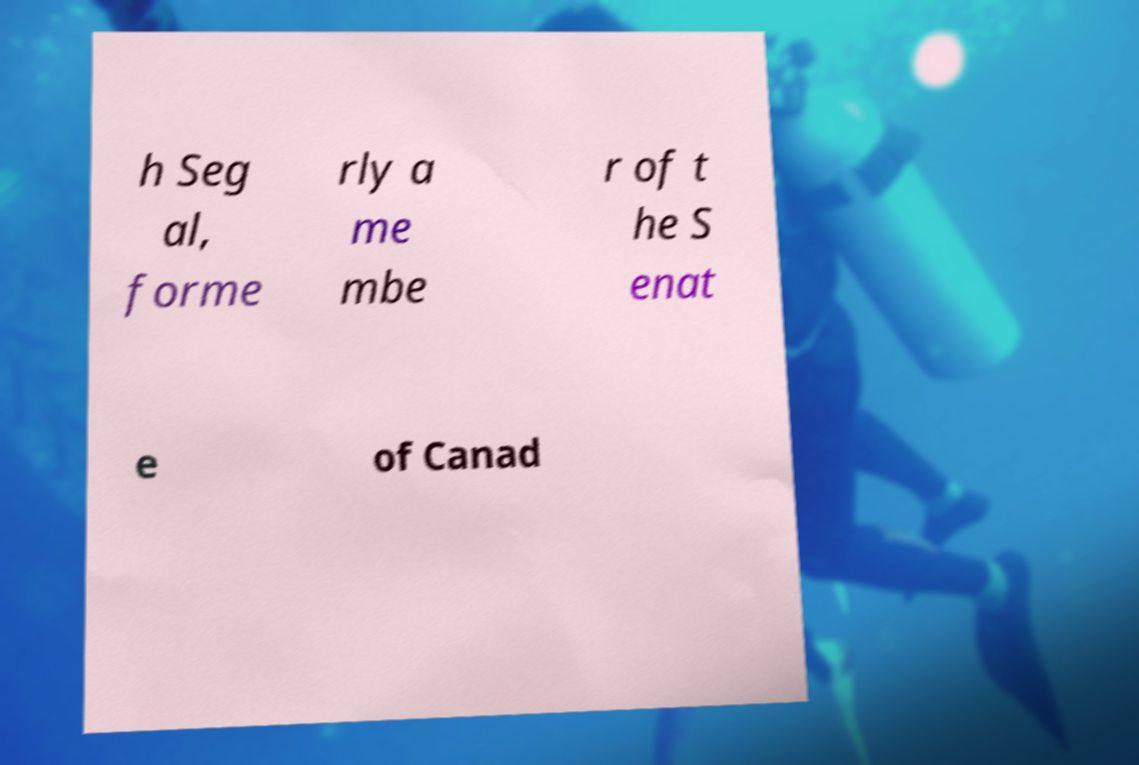There's text embedded in this image that I need extracted. Can you transcribe it verbatim? h Seg al, forme rly a me mbe r of t he S enat e of Canad 